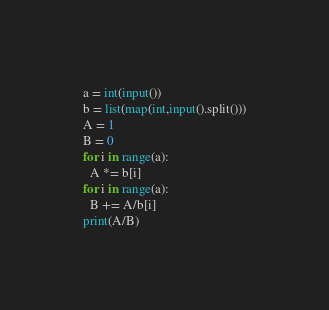<code> <loc_0><loc_0><loc_500><loc_500><_Python_>a = int(input())
b = list(map(int,input().split()))
A = 1
B = 0
for i in range(a):
  A *= b[i]
for i in range(a):
  B += A/b[i]
print(A/B)</code> 